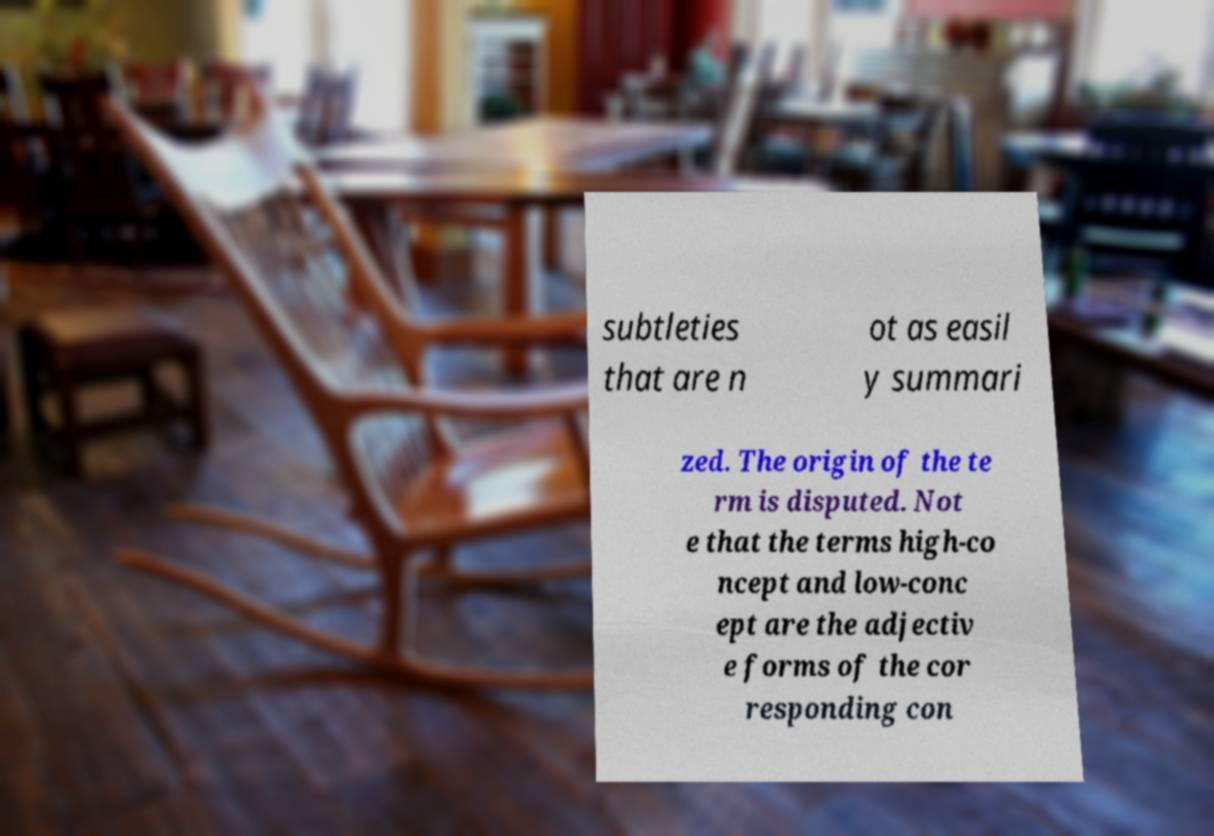Could you extract and type out the text from this image? subtleties that are n ot as easil y summari zed. The origin of the te rm is disputed. Not e that the terms high-co ncept and low-conc ept are the adjectiv e forms of the cor responding con 